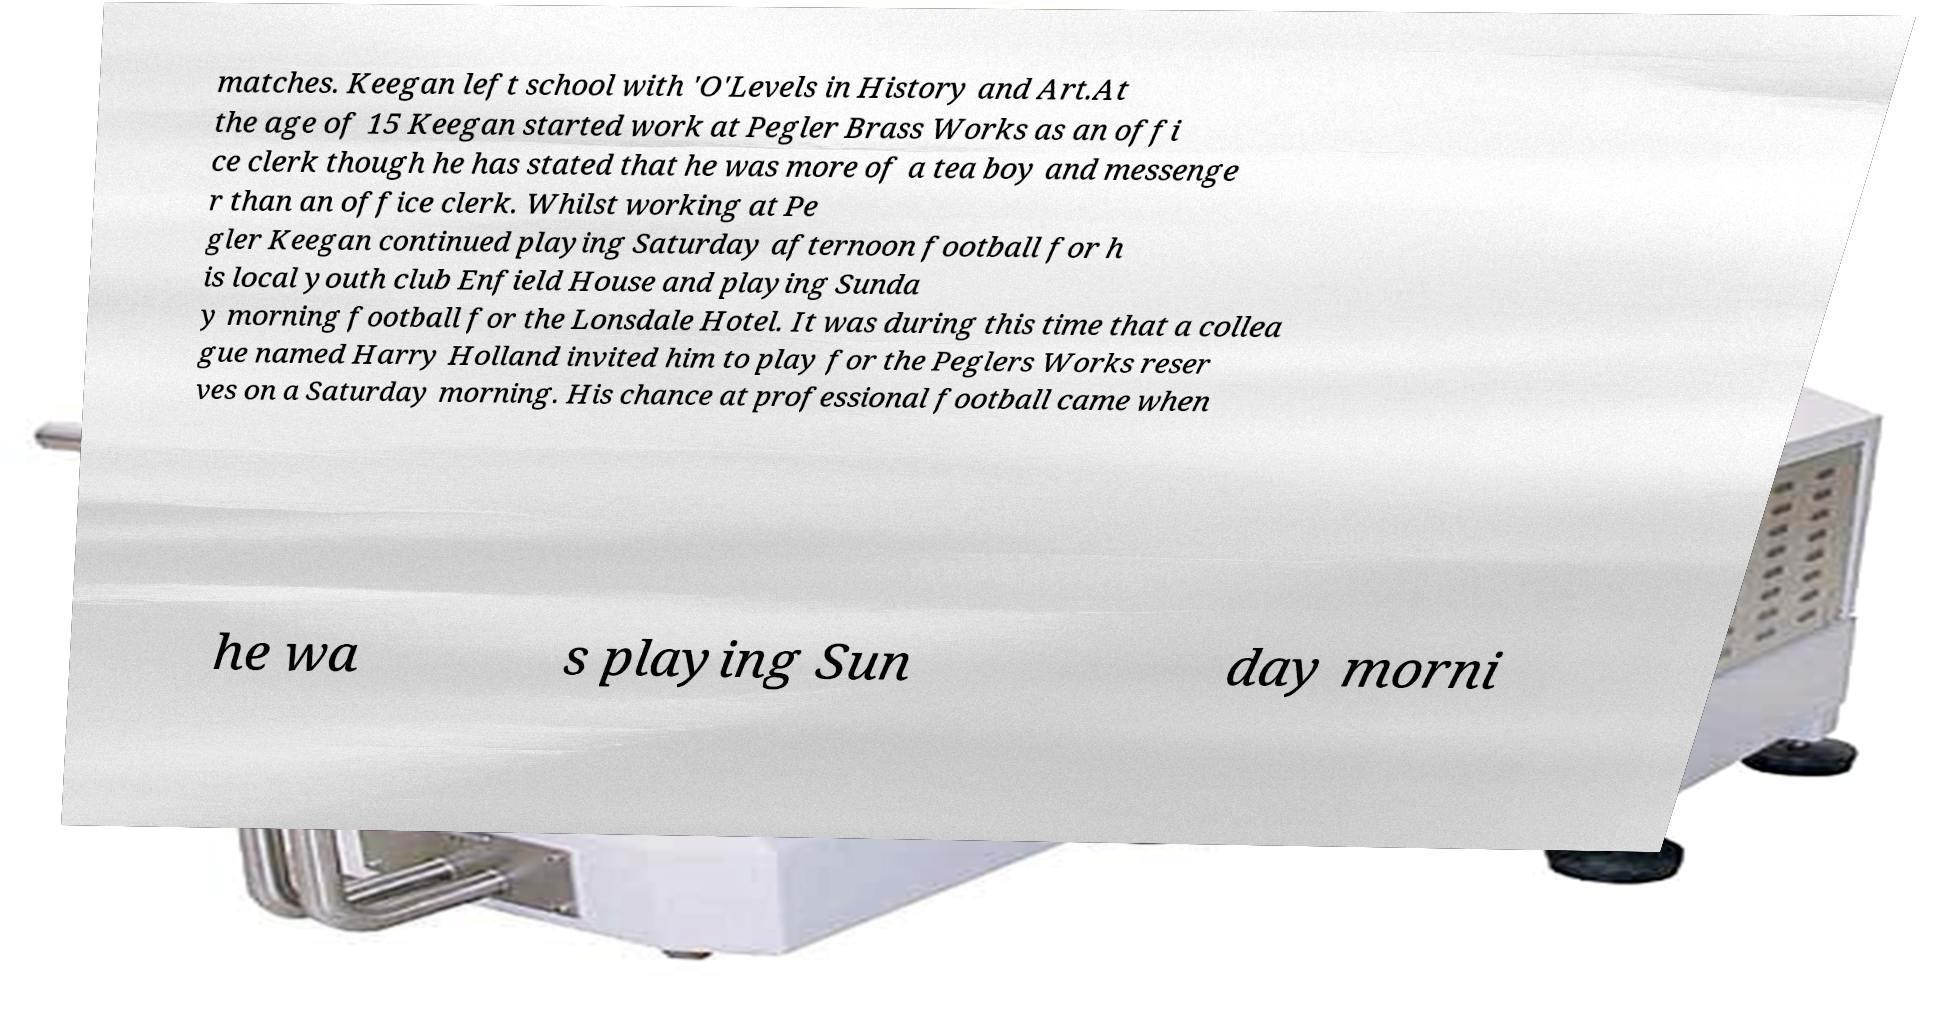Can you accurately transcribe the text from the provided image for me? matches. Keegan left school with 'O'Levels in History and Art.At the age of 15 Keegan started work at Pegler Brass Works as an offi ce clerk though he has stated that he was more of a tea boy and messenge r than an office clerk. Whilst working at Pe gler Keegan continued playing Saturday afternoon football for h is local youth club Enfield House and playing Sunda y morning football for the Lonsdale Hotel. It was during this time that a collea gue named Harry Holland invited him to play for the Peglers Works reser ves on a Saturday morning. His chance at professional football came when he wa s playing Sun day morni 